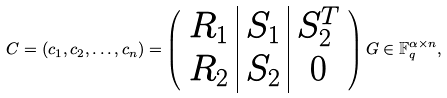Convert formula to latex. <formula><loc_0><loc_0><loc_500><loc_500>C = ( c _ { 1 } , c _ { 2 } , \dots , c _ { n } ) = \left ( \begin{array} { c | c | c } R _ { 1 } & S _ { 1 } & S _ { 2 } ^ { T } \\ R _ { 2 } & S _ { 2 } & 0 \end{array} \right ) G \in \mathbb { F } _ { q } ^ { \alpha \times n } ,</formula> 